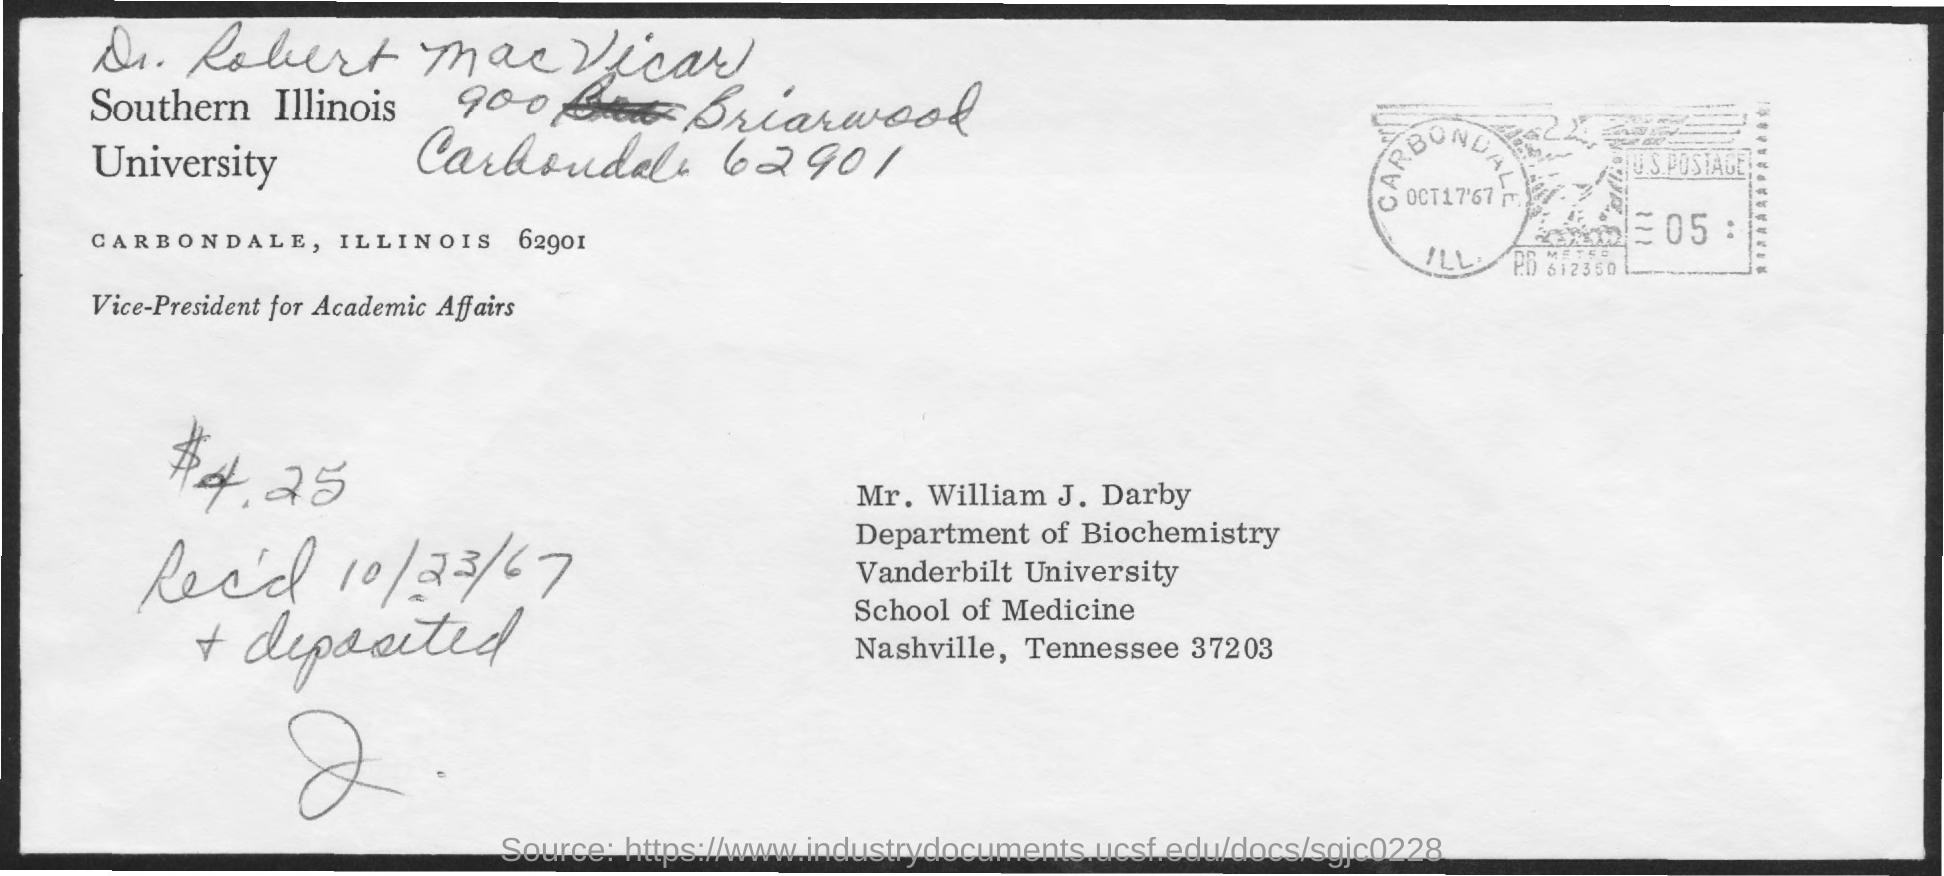Who's from the vanderbilt university as given in the address?
Offer a terse response. Mr. William J. Darby. What is the received date mentioned in the postal card?
Offer a very short reply. 10/23/67. 